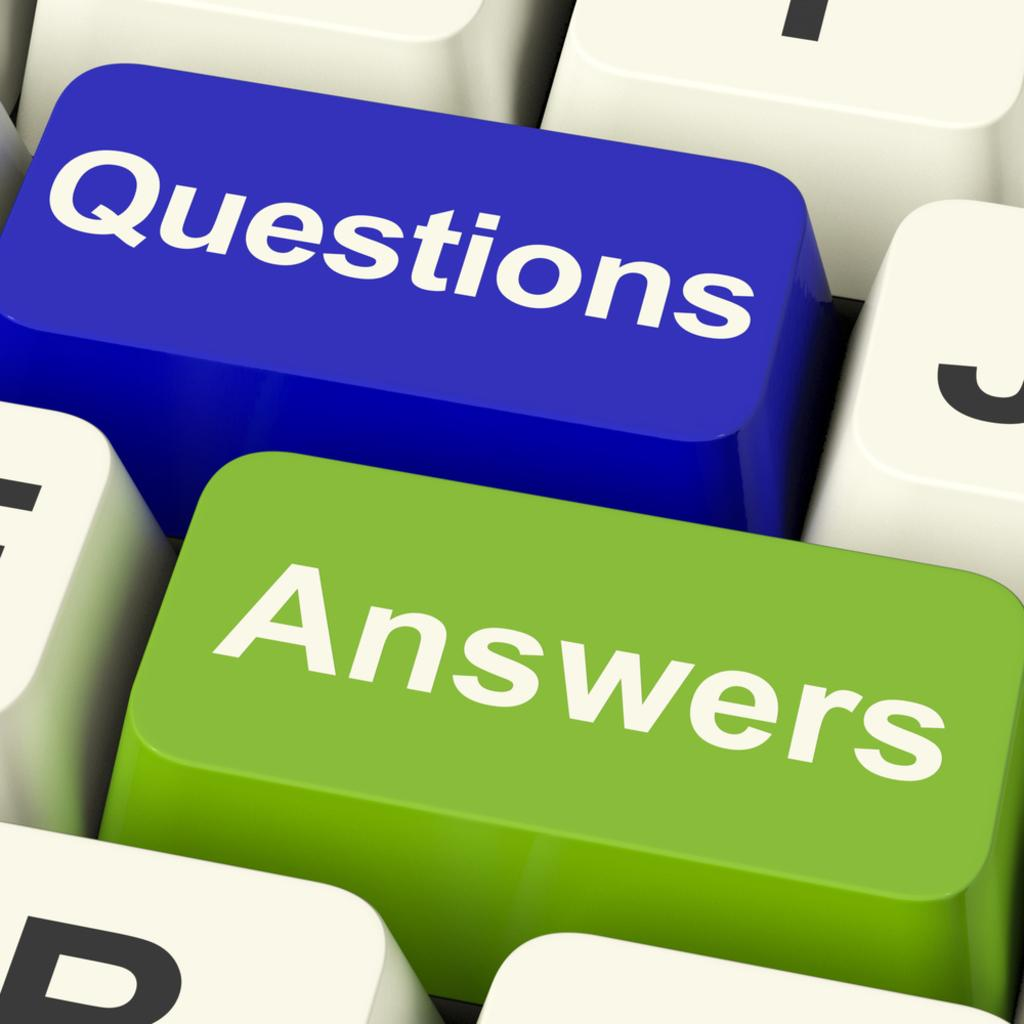<image>
Offer a succinct explanation of the picture presented. a computer keyboard with a blue key for Questions and green one for Answers 